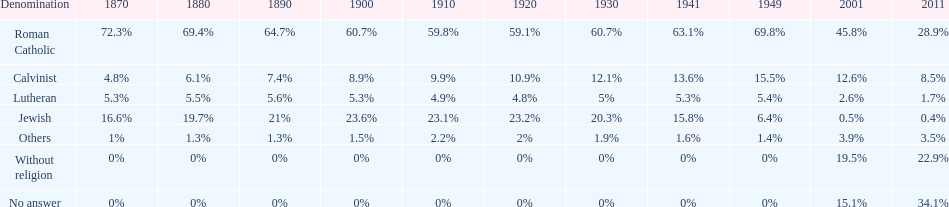After 1949, which denomination's share increased the most? Without religion. Would you mind parsing the complete table? {'header': ['Denomination', '1870', '1880', '1890', '1900', '1910', '1920', '1930', '1941', '1949', '2001', '2011'], 'rows': [['Roman Catholic', '72.3%', '69.4%', '64.7%', '60.7%', '59.8%', '59.1%', '60.7%', '63.1%', '69.8%', '45.8%', '28.9%'], ['Calvinist', '4.8%', '6.1%', '7.4%', '8.9%', '9.9%', '10.9%', '12.1%', '13.6%', '15.5%', '12.6%', '8.5%'], ['Lutheran', '5.3%', '5.5%', '5.6%', '5.3%', '4.9%', '4.8%', '5%', '5.3%', '5.4%', '2.6%', '1.7%'], ['Jewish', '16.6%', '19.7%', '21%', '23.6%', '23.1%', '23.2%', '20.3%', '15.8%', '6.4%', '0.5%', '0.4%'], ['Others', '1%', '1.3%', '1.3%', '1.5%', '2.2%', '2%', '1.9%', '1.6%', '1.4%', '3.9%', '3.5%'], ['Without religion', '0%', '0%', '0%', '0%', '0%', '0%', '0%', '0%', '0%', '19.5%', '22.9%'], ['No answer', '0%', '0%', '0%', '0%', '0%', '0%', '0%', '0%', '0%', '15.1%', '34.1%']]} 